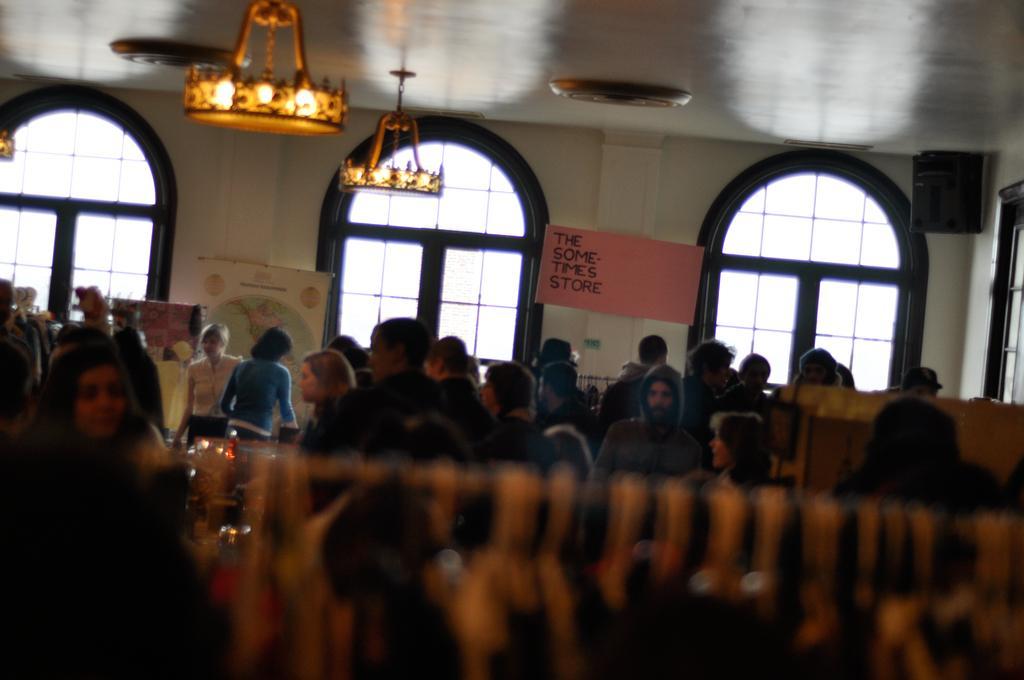Describe this image in one or two sentences. In this image in the center there are persons in the background. There are boards with some text written on it and there are windows, on the top there are chandeliers hanging and on the right side, on the top there is an object which is black in colour hanging. 